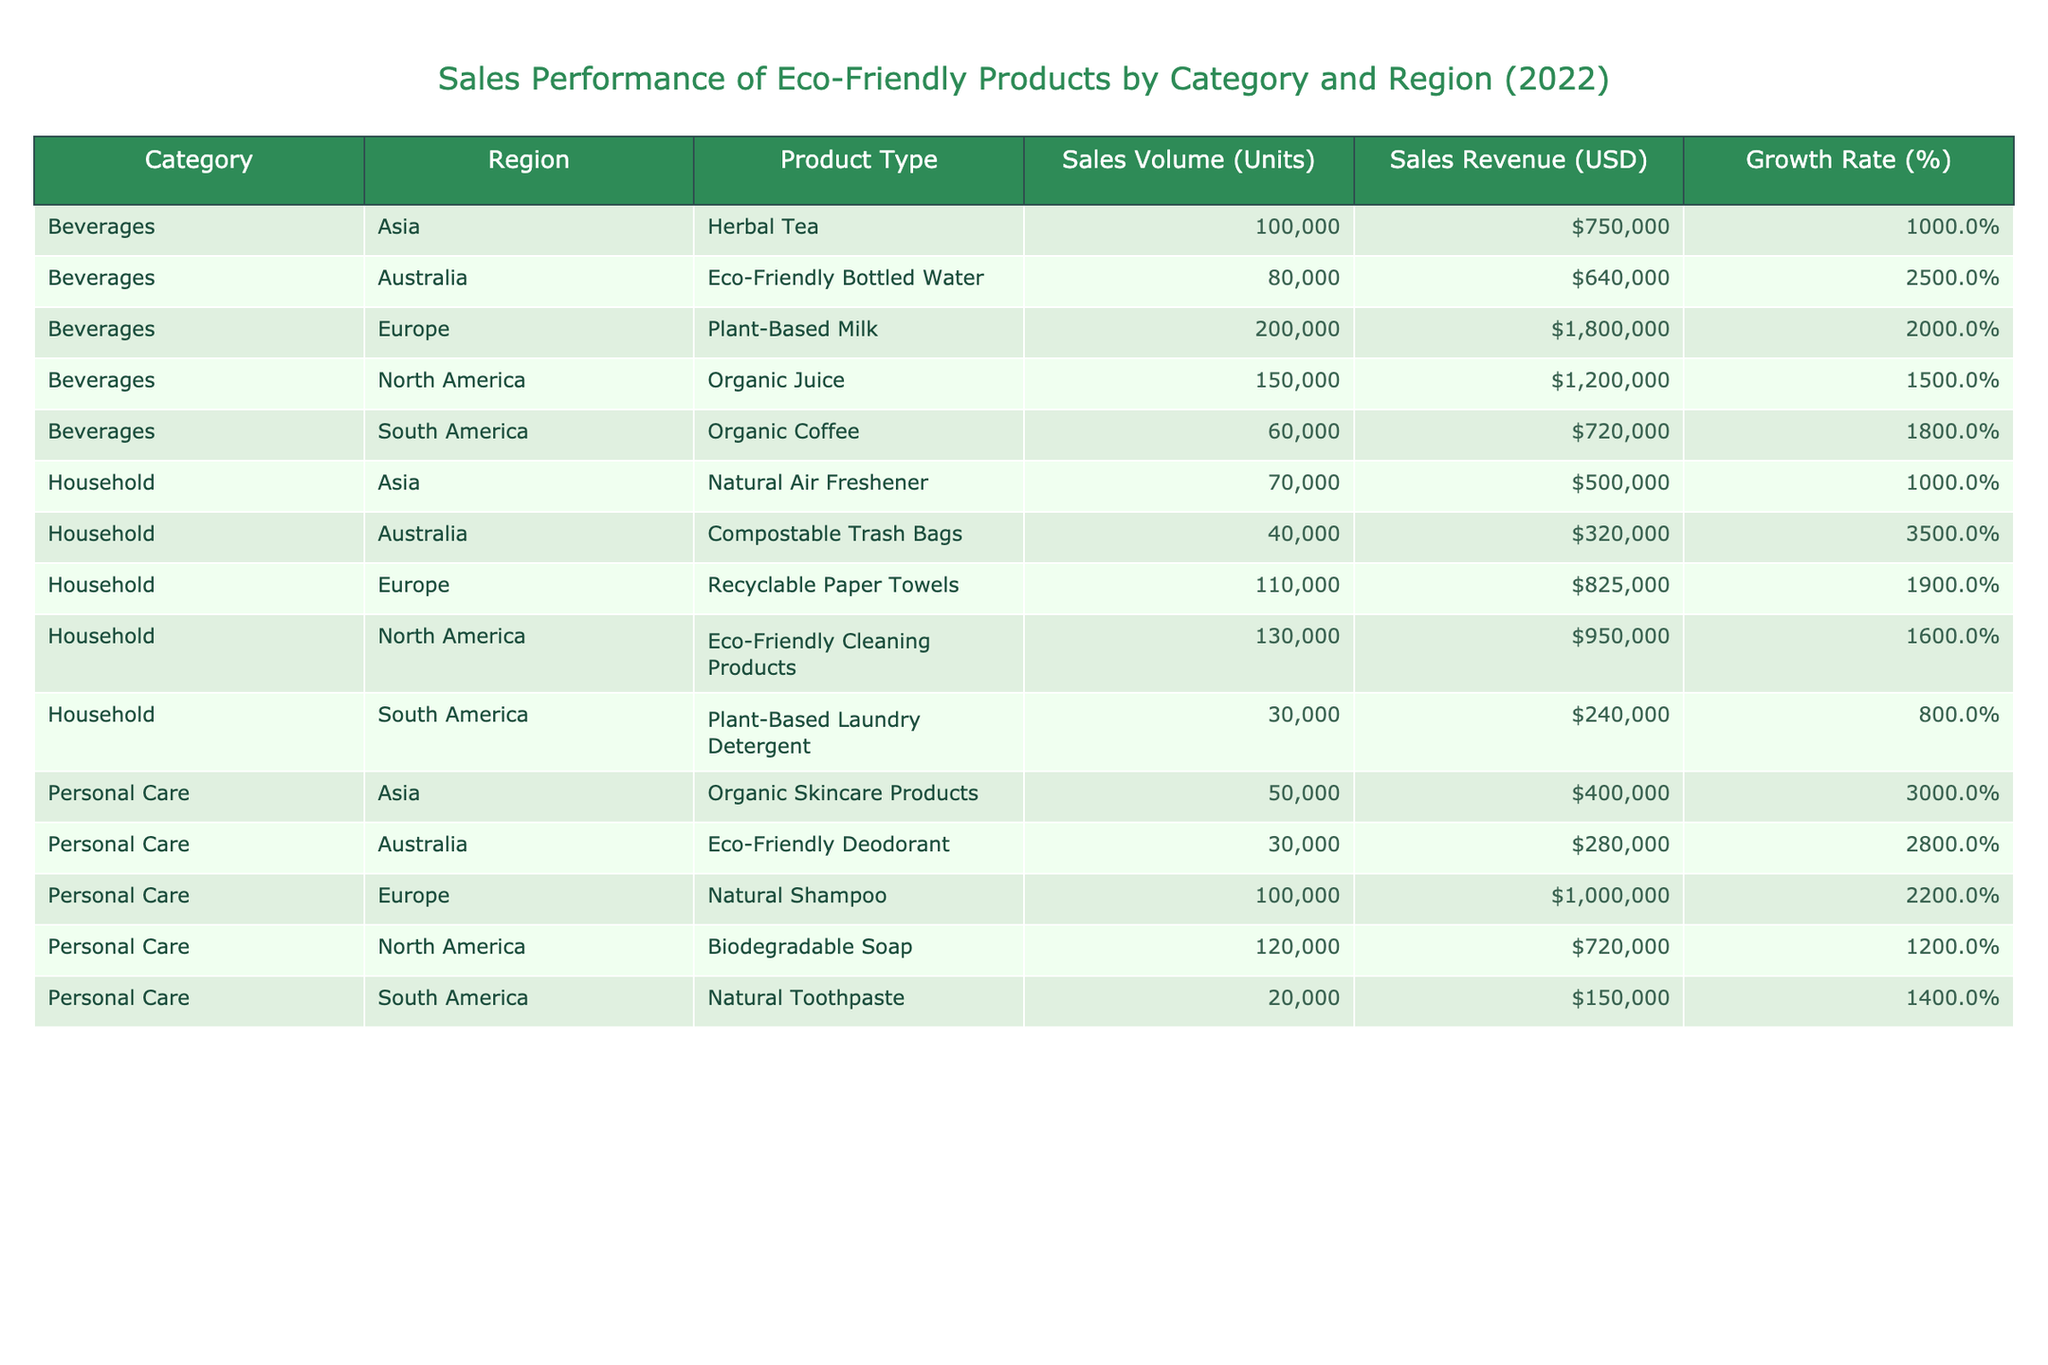What is the sales volume of Organic Juice in North America? The table shows the sales volume for each product. For Organic Juice in North America, the sales volume is specified as 150,000 units.
Answer: 150000 Which region had the highest growth rate in sales for eco-friendly products? By comparing the growth rates listed for each region, Eco-Friendly Bottled Water in Australia has the highest growth rate at 25%.
Answer: Australia What is the total sales revenue of Beverages across all regions? The sales revenue of Beverages is 1,200,000 (North America) + 1,800,000 (Europe) + 750,000 (Asia) + 640,000 (Australia) + 720,000 (South America) = 5,110,000 USD.
Answer: 5110000 Is the sales revenue for Natural Shampoo in Europe greater than that of Biodegradable Soap in North America? The revenue for Natural Shampoo in Europe is 1,000,000, while Biodegradable Soap in North America is 720,000. Since 1,000,000 is greater than 720,000, the statement is true.
Answer: Yes What is the average growth rate for Household products across all regions? The growth rates for Household products are 16% (North America), 19% (Europe), 10% (Asia), 35% (Australia), and 8% (South America). Adding these gives 16 + 19 + 10 + 35 + 8 = 88%. Dividing by 5 (the number of regions) results in an average growth rate of 17.6%.
Answer: 17.6 Which product type in Asia had the lowest sales volume? Looking at the sales volume for Personal Care in Asia, Organic Skincare Products have a sales volume of 50,000 units, whereas the other categories in Asia have higher sales volumes.
Answer: Organic Skincare Products How many more units of Plant-Based Milk were sold in Europe compared to Eco-Friendly Deodorant in Australia? The sales volume for Plant-Based Milk is 200,000 units and for Eco-Friendly Deodorant it is 30,000 units. The difference is 200,000 - 30,000 = 170,000 units.
Answer: 170000 Did organic products outperform non-organic ones in all regions? By examining the table, we see that in regions such as Asia and South America, non-organic products (like Natural Air Freshener and Plant-Based Laundry Detergent) had lower sales compared to organic products like Herbal Tea and Organic Coffee. Therefore, the statement is not true for all regions.
Answer: No What is the combined sales volume of eco-friendly products in North America? The combined sales volumes for North America are 150,000 (Beverages) + 120,000 (Personal Care) + 130,000 (Household) = 400,000 units.
Answer: 400000 